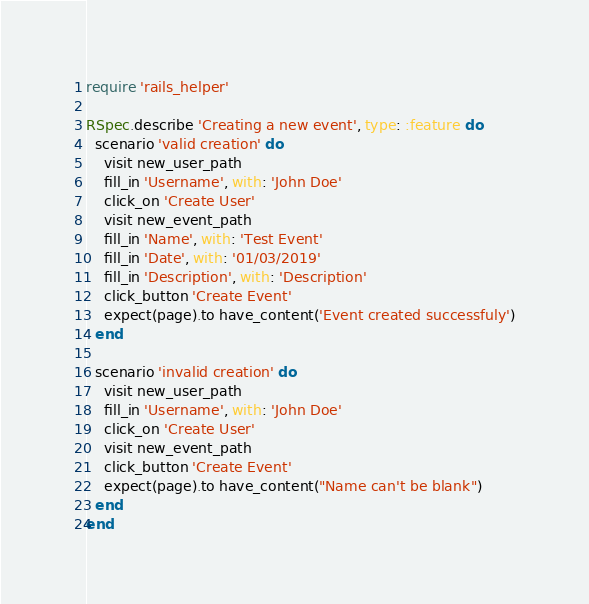<code> <loc_0><loc_0><loc_500><loc_500><_Ruby_>require 'rails_helper'

RSpec.describe 'Creating a new event', type: :feature do
  scenario 'valid creation' do
    visit new_user_path
    fill_in 'Username', with: 'John Doe'
    click_on 'Create User'
    visit new_event_path
    fill_in 'Name', with: 'Test Event'
    fill_in 'Date', with: '01/03/2019'
    fill_in 'Description', with: 'Description'
    click_button 'Create Event'
    expect(page).to have_content('Event created successfuly')
  end

  scenario 'invalid creation' do
    visit new_user_path
    fill_in 'Username', with: 'John Doe'
    click_on 'Create User'
    visit new_event_path
    click_button 'Create Event'
    expect(page).to have_content("Name can't be blank")
  end
end
</code> 